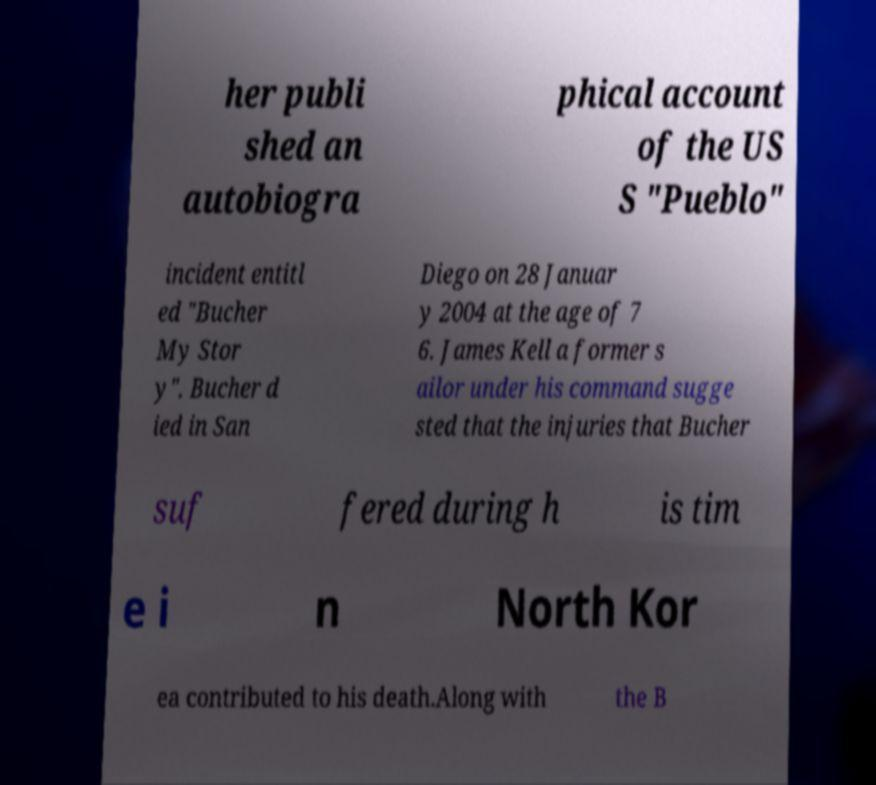Please read and relay the text visible in this image. What does it say? her publi shed an autobiogra phical account of the US S "Pueblo" incident entitl ed "Bucher My Stor y". Bucher d ied in San Diego on 28 Januar y 2004 at the age of 7 6. James Kell a former s ailor under his command sugge sted that the injuries that Bucher suf fered during h is tim e i n North Kor ea contributed to his death.Along with the B 